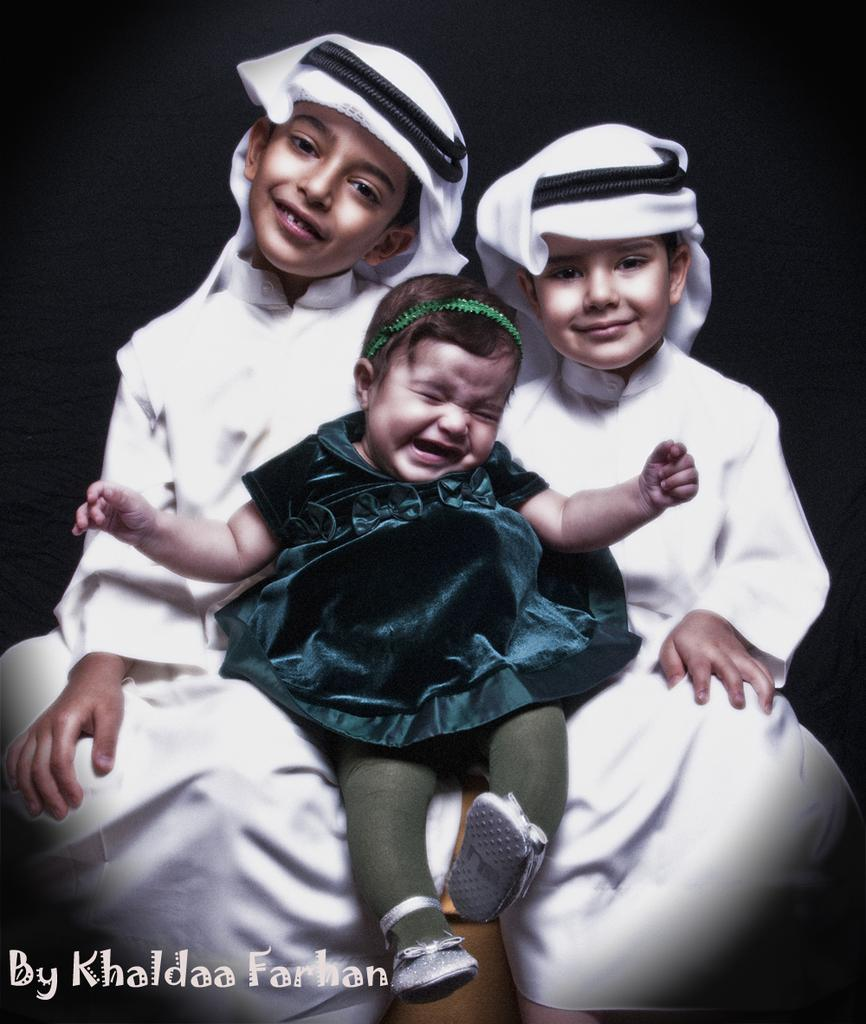How many people are in the image? There are three persons in the image. What can be seen in the bottom left side of the image? There is a watermark in the bottom left side of the image. What is the color of the background in the image? The background of the image is dark. What type of learning material is being used by the women in the image? There is no indication of any learning material or women present in the image. 